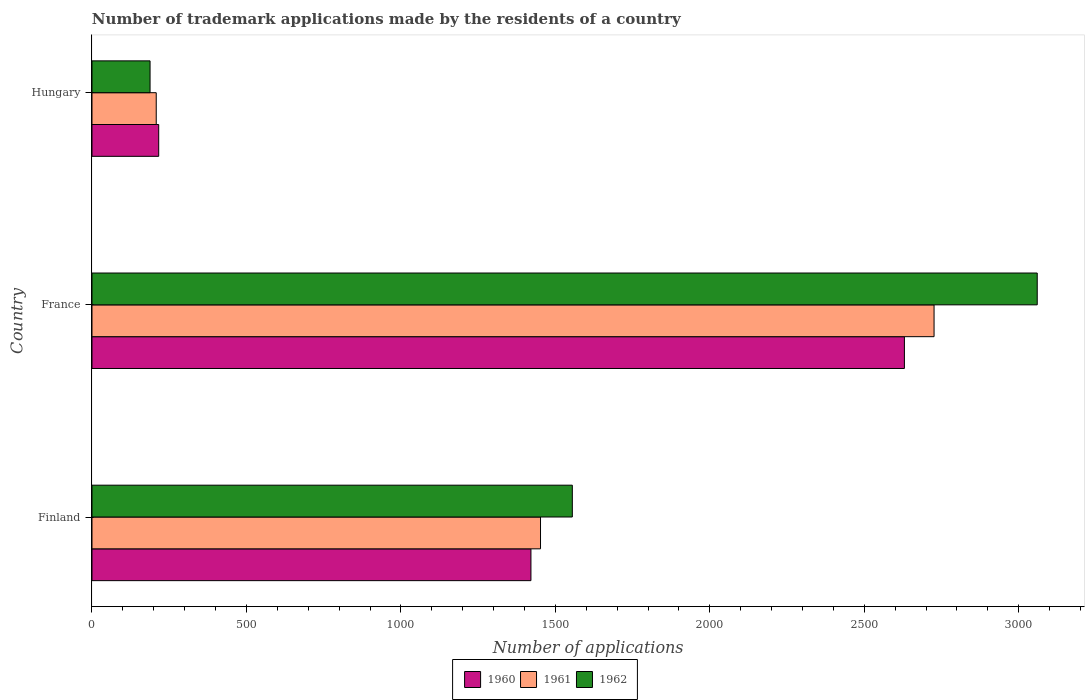How many groups of bars are there?
Provide a short and direct response. 3. Are the number of bars on each tick of the Y-axis equal?
Your response must be concise. Yes. How many bars are there on the 3rd tick from the bottom?
Your answer should be compact. 3. What is the label of the 2nd group of bars from the top?
Your answer should be compact. France. What is the number of trademark applications made by the residents in 1960 in Finland?
Ensure brevity in your answer.  1421. Across all countries, what is the maximum number of trademark applications made by the residents in 1960?
Ensure brevity in your answer.  2630. Across all countries, what is the minimum number of trademark applications made by the residents in 1960?
Your answer should be very brief. 216. In which country was the number of trademark applications made by the residents in 1960 minimum?
Ensure brevity in your answer.  Hungary. What is the total number of trademark applications made by the residents in 1961 in the graph?
Offer a very short reply. 4386. What is the difference between the number of trademark applications made by the residents in 1961 in France and that in Hungary?
Make the answer very short. 2518. What is the difference between the number of trademark applications made by the residents in 1962 in France and the number of trademark applications made by the residents in 1960 in Finland?
Provide a succinct answer. 1639. What is the average number of trademark applications made by the residents in 1960 per country?
Make the answer very short. 1422.33. What is the difference between the number of trademark applications made by the residents in 1960 and number of trademark applications made by the residents in 1962 in Finland?
Your answer should be very brief. -134. In how many countries, is the number of trademark applications made by the residents in 1960 greater than 1200 ?
Offer a terse response. 2. What is the ratio of the number of trademark applications made by the residents in 1962 in France to that in Hungary?
Provide a short and direct response. 16.28. Is the difference between the number of trademark applications made by the residents in 1960 in France and Hungary greater than the difference between the number of trademark applications made by the residents in 1962 in France and Hungary?
Offer a very short reply. No. What is the difference between the highest and the second highest number of trademark applications made by the residents in 1960?
Ensure brevity in your answer.  1209. What is the difference between the highest and the lowest number of trademark applications made by the residents in 1961?
Your answer should be very brief. 2518. What does the 3rd bar from the bottom in Finland represents?
Offer a terse response. 1962. Are all the bars in the graph horizontal?
Offer a terse response. Yes. What is the difference between two consecutive major ticks on the X-axis?
Give a very brief answer. 500. Does the graph contain grids?
Your answer should be very brief. No. How many legend labels are there?
Ensure brevity in your answer.  3. What is the title of the graph?
Keep it short and to the point. Number of trademark applications made by the residents of a country. What is the label or title of the X-axis?
Provide a short and direct response. Number of applications. What is the label or title of the Y-axis?
Offer a very short reply. Country. What is the Number of applications of 1960 in Finland?
Provide a succinct answer. 1421. What is the Number of applications of 1961 in Finland?
Keep it short and to the point. 1452. What is the Number of applications in 1962 in Finland?
Offer a terse response. 1555. What is the Number of applications of 1960 in France?
Make the answer very short. 2630. What is the Number of applications in 1961 in France?
Give a very brief answer. 2726. What is the Number of applications of 1962 in France?
Provide a succinct answer. 3060. What is the Number of applications in 1960 in Hungary?
Your answer should be very brief. 216. What is the Number of applications in 1961 in Hungary?
Give a very brief answer. 208. What is the Number of applications in 1962 in Hungary?
Provide a succinct answer. 188. Across all countries, what is the maximum Number of applications of 1960?
Your answer should be compact. 2630. Across all countries, what is the maximum Number of applications in 1961?
Offer a very short reply. 2726. Across all countries, what is the maximum Number of applications of 1962?
Your answer should be compact. 3060. Across all countries, what is the minimum Number of applications of 1960?
Ensure brevity in your answer.  216. Across all countries, what is the minimum Number of applications of 1961?
Your answer should be compact. 208. Across all countries, what is the minimum Number of applications in 1962?
Provide a succinct answer. 188. What is the total Number of applications of 1960 in the graph?
Make the answer very short. 4267. What is the total Number of applications in 1961 in the graph?
Keep it short and to the point. 4386. What is the total Number of applications in 1962 in the graph?
Offer a very short reply. 4803. What is the difference between the Number of applications in 1960 in Finland and that in France?
Make the answer very short. -1209. What is the difference between the Number of applications of 1961 in Finland and that in France?
Your answer should be very brief. -1274. What is the difference between the Number of applications of 1962 in Finland and that in France?
Offer a very short reply. -1505. What is the difference between the Number of applications in 1960 in Finland and that in Hungary?
Give a very brief answer. 1205. What is the difference between the Number of applications of 1961 in Finland and that in Hungary?
Provide a succinct answer. 1244. What is the difference between the Number of applications of 1962 in Finland and that in Hungary?
Provide a short and direct response. 1367. What is the difference between the Number of applications of 1960 in France and that in Hungary?
Provide a short and direct response. 2414. What is the difference between the Number of applications of 1961 in France and that in Hungary?
Offer a very short reply. 2518. What is the difference between the Number of applications of 1962 in France and that in Hungary?
Make the answer very short. 2872. What is the difference between the Number of applications of 1960 in Finland and the Number of applications of 1961 in France?
Provide a succinct answer. -1305. What is the difference between the Number of applications of 1960 in Finland and the Number of applications of 1962 in France?
Make the answer very short. -1639. What is the difference between the Number of applications of 1961 in Finland and the Number of applications of 1962 in France?
Offer a very short reply. -1608. What is the difference between the Number of applications of 1960 in Finland and the Number of applications of 1961 in Hungary?
Provide a succinct answer. 1213. What is the difference between the Number of applications of 1960 in Finland and the Number of applications of 1962 in Hungary?
Your answer should be very brief. 1233. What is the difference between the Number of applications in 1961 in Finland and the Number of applications in 1962 in Hungary?
Offer a very short reply. 1264. What is the difference between the Number of applications in 1960 in France and the Number of applications in 1961 in Hungary?
Offer a very short reply. 2422. What is the difference between the Number of applications in 1960 in France and the Number of applications in 1962 in Hungary?
Offer a terse response. 2442. What is the difference between the Number of applications in 1961 in France and the Number of applications in 1962 in Hungary?
Provide a short and direct response. 2538. What is the average Number of applications in 1960 per country?
Make the answer very short. 1422.33. What is the average Number of applications of 1961 per country?
Your answer should be very brief. 1462. What is the average Number of applications in 1962 per country?
Make the answer very short. 1601. What is the difference between the Number of applications of 1960 and Number of applications of 1961 in Finland?
Offer a very short reply. -31. What is the difference between the Number of applications of 1960 and Number of applications of 1962 in Finland?
Your answer should be very brief. -134. What is the difference between the Number of applications of 1961 and Number of applications of 1962 in Finland?
Keep it short and to the point. -103. What is the difference between the Number of applications of 1960 and Number of applications of 1961 in France?
Your answer should be very brief. -96. What is the difference between the Number of applications of 1960 and Number of applications of 1962 in France?
Ensure brevity in your answer.  -430. What is the difference between the Number of applications of 1961 and Number of applications of 1962 in France?
Give a very brief answer. -334. What is the difference between the Number of applications in 1960 and Number of applications in 1962 in Hungary?
Give a very brief answer. 28. What is the difference between the Number of applications in 1961 and Number of applications in 1962 in Hungary?
Provide a succinct answer. 20. What is the ratio of the Number of applications in 1960 in Finland to that in France?
Offer a terse response. 0.54. What is the ratio of the Number of applications in 1961 in Finland to that in France?
Keep it short and to the point. 0.53. What is the ratio of the Number of applications of 1962 in Finland to that in France?
Offer a very short reply. 0.51. What is the ratio of the Number of applications of 1960 in Finland to that in Hungary?
Ensure brevity in your answer.  6.58. What is the ratio of the Number of applications of 1961 in Finland to that in Hungary?
Give a very brief answer. 6.98. What is the ratio of the Number of applications in 1962 in Finland to that in Hungary?
Ensure brevity in your answer.  8.27. What is the ratio of the Number of applications in 1960 in France to that in Hungary?
Provide a succinct answer. 12.18. What is the ratio of the Number of applications in 1961 in France to that in Hungary?
Your answer should be compact. 13.11. What is the ratio of the Number of applications in 1962 in France to that in Hungary?
Offer a terse response. 16.28. What is the difference between the highest and the second highest Number of applications of 1960?
Ensure brevity in your answer.  1209. What is the difference between the highest and the second highest Number of applications in 1961?
Ensure brevity in your answer.  1274. What is the difference between the highest and the second highest Number of applications of 1962?
Offer a very short reply. 1505. What is the difference between the highest and the lowest Number of applications of 1960?
Your answer should be very brief. 2414. What is the difference between the highest and the lowest Number of applications in 1961?
Keep it short and to the point. 2518. What is the difference between the highest and the lowest Number of applications of 1962?
Your answer should be very brief. 2872. 